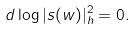<formula> <loc_0><loc_0><loc_500><loc_500>d \log | s ( w ) | ^ { 2 } _ { h } = 0 .</formula> 